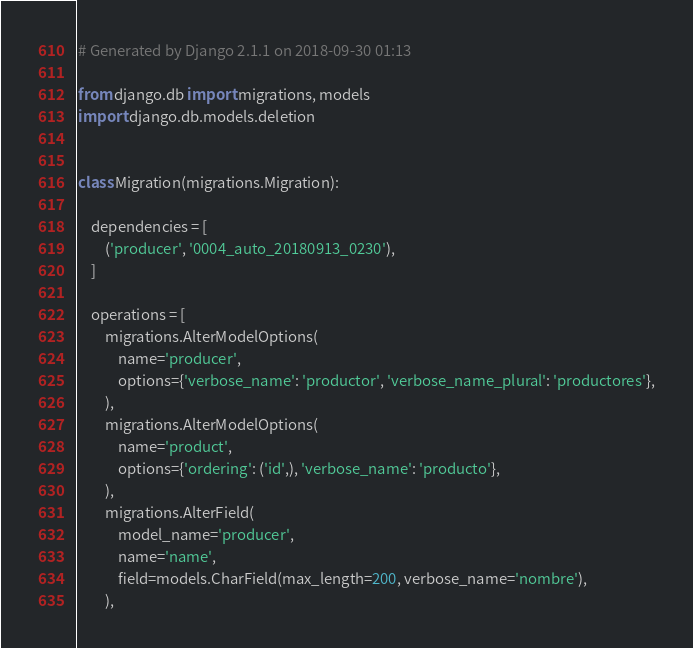<code> <loc_0><loc_0><loc_500><loc_500><_Python_># Generated by Django 2.1.1 on 2018-09-30 01:13

from django.db import migrations, models
import django.db.models.deletion


class Migration(migrations.Migration):

    dependencies = [
        ('producer', '0004_auto_20180913_0230'),
    ]

    operations = [
        migrations.AlterModelOptions(
            name='producer',
            options={'verbose_name': 'productor', 'verbose_name_plural': 'productores'},
        ),
        migrations.AlterModelOptions(
            name='product',
            options={'ordering': ('id',), 'verbose_name': 'producto'},
        ),
        migrations.AlterField(
            model_name='producer',
            name='name',
            field=models.CharField(max_length=200, verbose_name='nombre'),
        ),</code> 